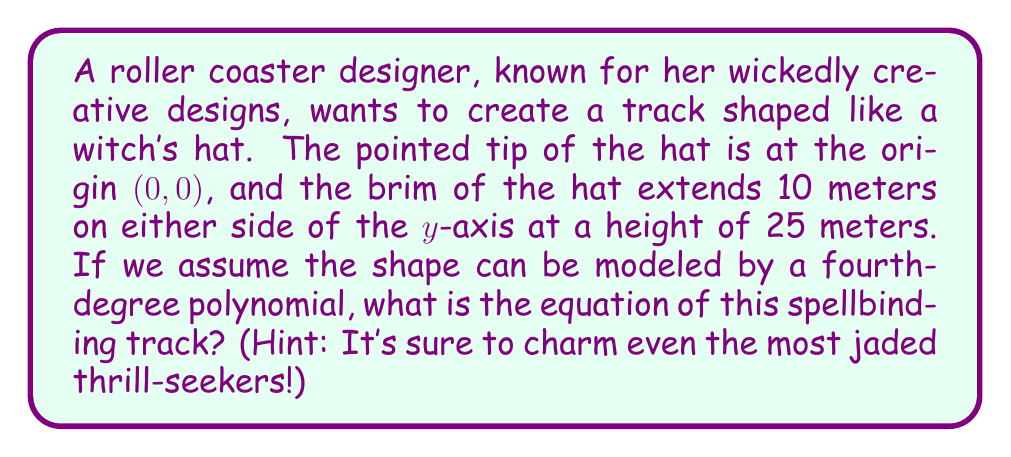Help me with this question. Let's brew up this polynomial potion step by step:

1) We know the polynomial is of degree 4, so it has the general form:
   $$f(x) = ax^4 + bx^3 + cx^2 + dx + e$$

2) We can use the given information to create a system of equations:
   - The tip of the hat is at (0, 0), so $f(0) = 0$
   - The brim extends 10 meters on either side at a height of 25 meters, so $f(10) = f(-10) = 25$
   - The curve should be symmetric, so $b = d = 0$

3) Applying these conditions:
   - $f(0) = e = 0$
   - $f(10) = 10000a + 100c = 25$
   - $f(-10) = 10000a + 100c = 25$ (same as above due to symmetry)

4) We need one more condition. Let's make the slope zero at x = ±10 for a smooth brim:
   $f'(x) = 4ax^3 + 2cx$
   $f'(10) = 4000a + 20c = 0$

5) Now we have a system of two equations:
   $10000a + 100c = 25$
   $4000a + 20c = 0$

6) Solving this system:
   From the second equation: $c = -200a$
   Substituting into the first equation:
   $10000a + 100(-200a) = 25$
   $10000a - 20000a = 25$
   $-10000a = 25$
   $a = -0.0025$

   Then, $c = -200(-0.0025) = 0.5$

7) Therefore, our enchanting equation is:
   $$f(x) = -0.0025x^4 + 0.5x^2$$

Abracadabra! The witch's hat track is mathematically conjured!
Answer: $f(x) = -0.0025x^4 + 0.5x^2$ 